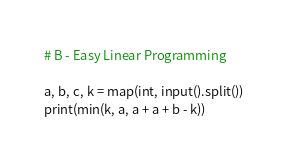<code> <loc_0><loc_0><loc_500><loc_500><_Python_># B - Easy Linear Programming

a, b, c, k = map(int, input().split())
print(min(k, a, a + a + b - k))
</code> 